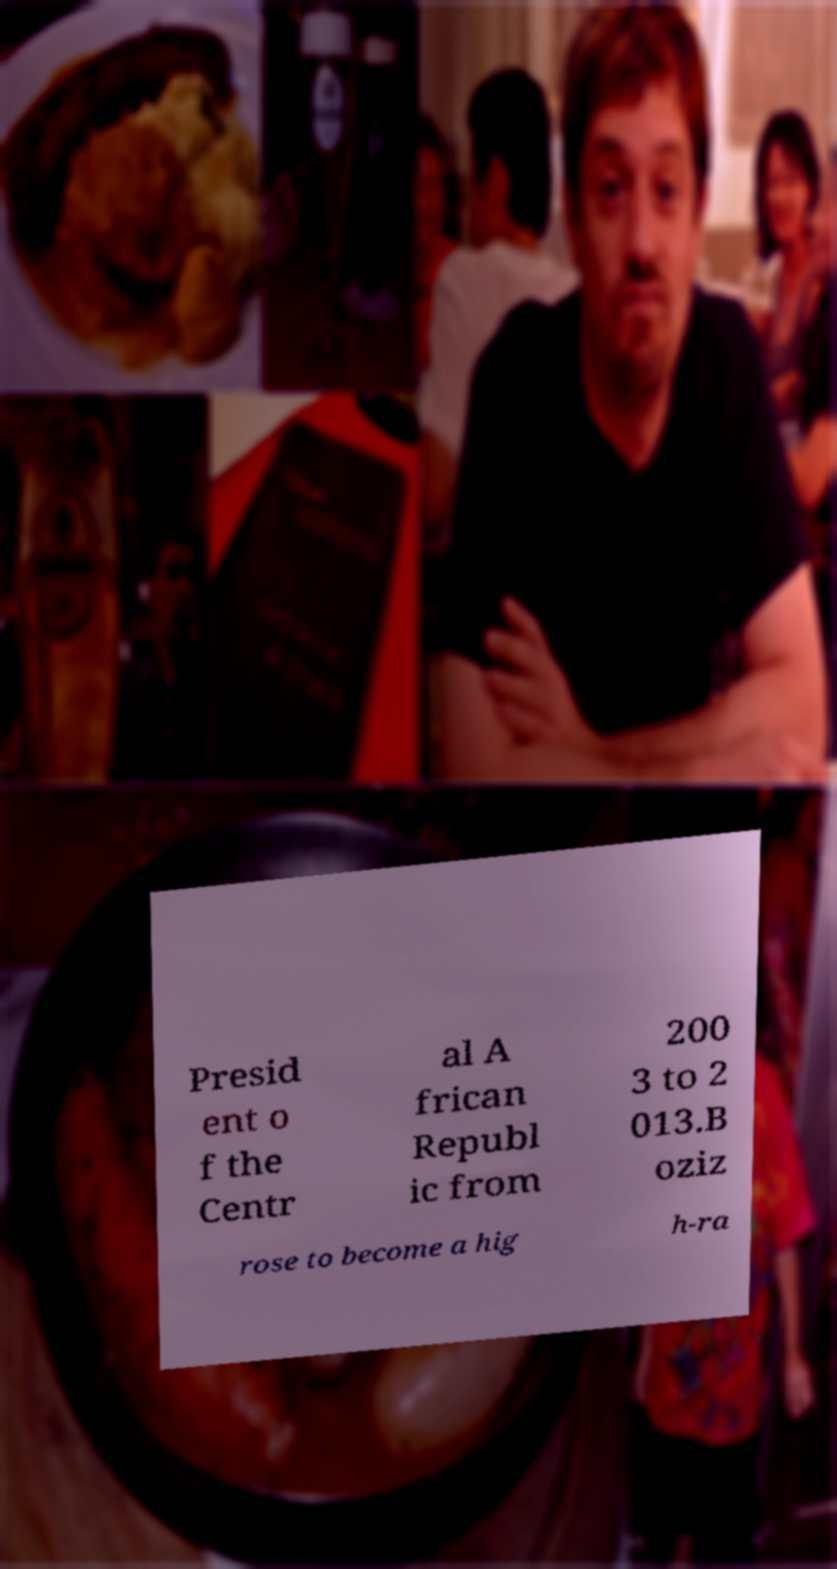Please identify and transcribe the text found in this image. Presid ent o f the Centr al A frican Republ ic from 200 3 to 2 013.B oziz rose to become a hig h-ra 